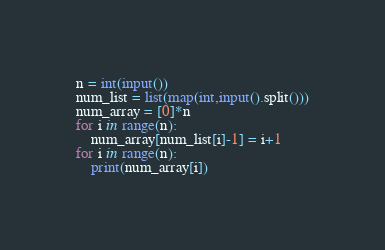Convert code to text. <code><loc_0><loc_0><loc_500><loc_500><_Python_>n = int(input())
num_list = list(map(int,input().split()))
num_array = [0]*n
for i in range(n):
    num_array[num_list[i]-1] = i+1
for i in range(n):
    print(num_array[i])
</code> 